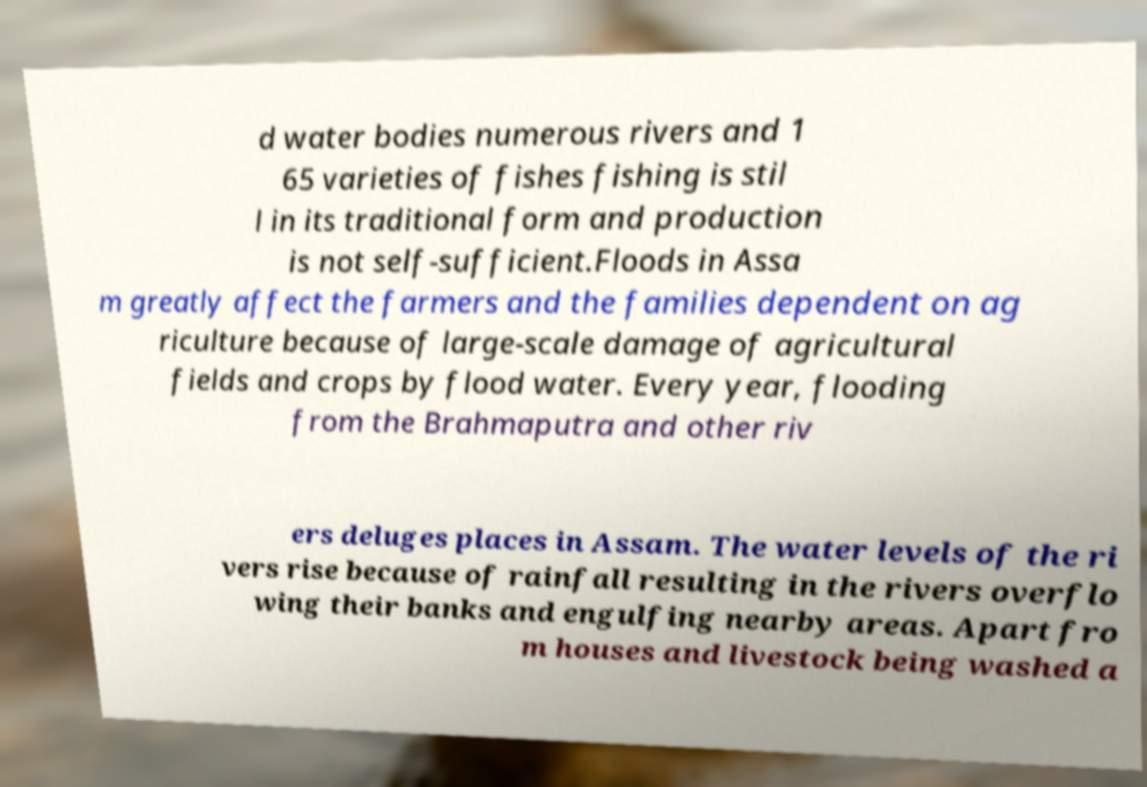Could you assist in decoding the text presented in this image and type it out clearly? d water bodies numerous rivers and 1 65 varieties of fishes fishing is stil l in its traditional form and production is not self-sufficient.Floods in Assa m greatly affect the farmers and the families dependent on ag riculture because of large-scale damage of agricultural fields and crops by flood water. Every year, flooding from the Brahmaputra and other riv ers deluges places in Assam. The water levels of the ri vers rise because of rainfall resulting in the rivers overflo wing their banks and engulfing nearby areas. Apart fro m houses and livestock being washed a 